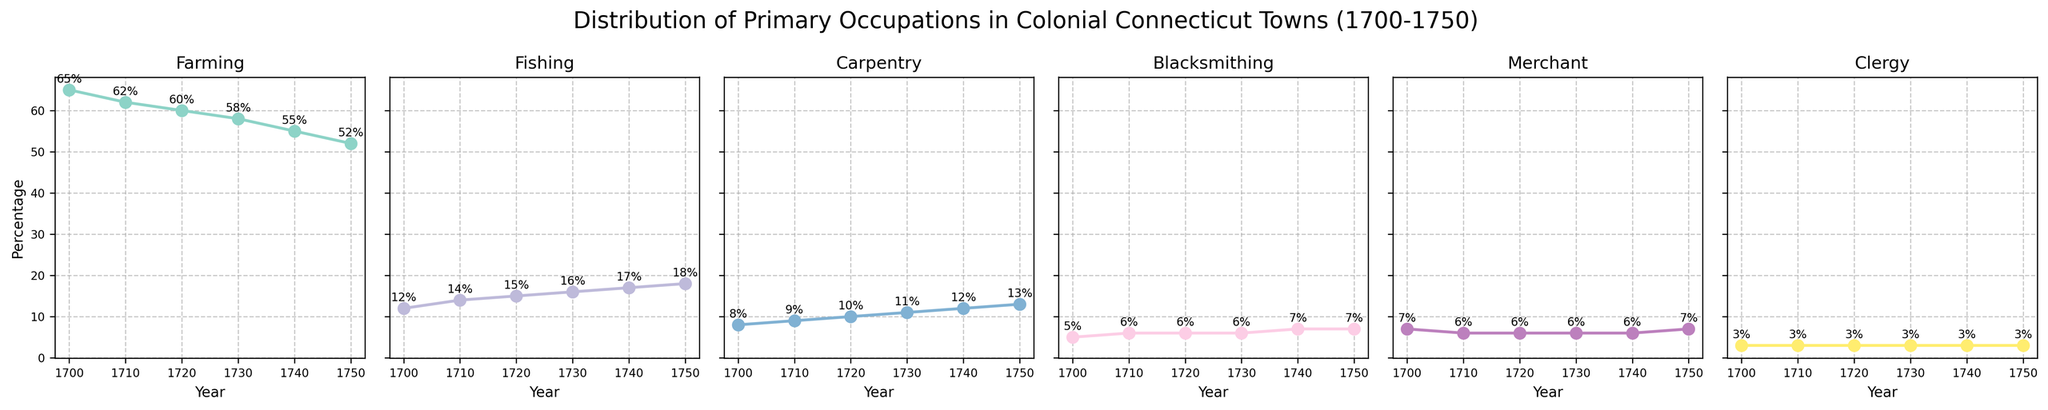How did the percentage of Farming occupations change from 1700 to 1750? Look at the occupation trend for Farming from 1700 to 1750. In 1700, it is 65%, and in 1750, it is 52%. The change is 65% - 52% = 13%.
Answer: It decreased by 13% Between 1720 and 1740, by what percentage did the Fishing occupation increase? Identify the percentages of Fishing for the years 1720 (15%) and 1740 (17%). The increase is 17% - 15% = 2%.
Answer: 2% Which occupation had the smallest change in percentage from 1700 to 1750? Examine the changes in percentage for each occupation from 1700 to 1750. Clergy remained constant at 3%.
Answer: Clergy How does the rate of change for Carpentry compare between 1700-1730 and 1730-1750? Calculate the percentage increase for Carpentry from 1700-1730: 11% - 8% = 3%. Then, calculate from 1730-1750: 13% - 11% = 2%. Thus, the rate of change was higher between 1700-1730.
Answer: Higher in 1700-1730 In which year was the percentage of Blacksmiths equivalent to the percentage of Clergy? Compare the percentages for Blacksmiths and Clergy across all years. In 1700, the percentage of Blacksmiths (5%) matches the percentage of Clergy (3%).
Answer: Never Looking at the Fishing occupation, during which decade was the largest increase observed? Determine the changes for each decade: 1700-1710 (2%), 1710-1720 (1%), 1720-1730 (1%), 1730-1740 (1%), 1740-1750 (1%). The largest increase happened from 1700 to 1710.
Answer: 1700-1710 By how much did the Merchant occupation increase from 1700 to 1750? Look at the percentages for Merchant in 1700 (7%) and in 1750 (7%). The increase is 7% - 7% = 0%.
Answer: No increase Which occupation consistently grew in percentage across each decade from 1700 to 1750? Examine the trend lines for each occupation. Fishing shows a consistent increase every decade.
Answer: Fishing Which year had the highest percentage of people in Blacksmithing? Look at the percentages for Blacksmithing throughout the years. 1740 and 1750 both show 7%.
Answer: 1740 and 1750 Compare the percentages of Farming and Fishing in 1720. How many times greater is the Farming occupation than Fishing in that year? Look at the percentages: Farming (60%), Fishing (15%). Calculate the ratio: 60% / 15% = 4.
Answer: 4 times 